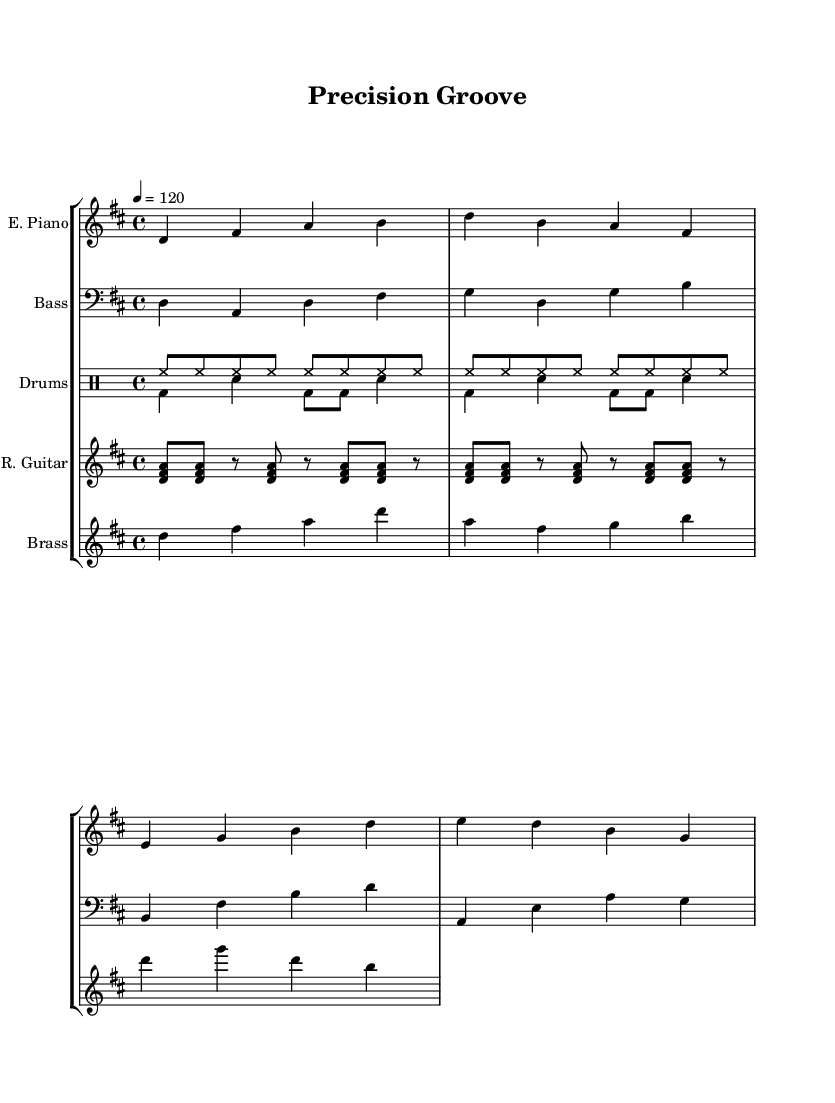What is the key signature of this music? The key signature shows two sharps, which indicate it is in the key of D major.
Answer: D major What is the time signature of this piece? The time signature is indicated by the fraction at the beginning of the score, which shows 4/4, meaning there are four beats in each measure.
Answer: 4/4 What is the tempo marking? The tempo is indicated as 4 equals 120, meaning there are 120 quarter note beats per minute.
Answer: 120 What type of instrumentation is featured in this music? The score lists six staffs, comprising electric piano, bass guitar, drums, rhythm guitar, and brass section, indicating a mix of keyboard, percussion, and harmony instruments typical in soul funk.
Answer: Electric piano, bass, drums, rhythm guitar, brass How many measures are there in the electric piano part? Counting the measures indicated in the electric piano part, there are a total of four measures shown in the music.
Answer: Four Which rhythmic section emphasizes the groove in the arrangement? The rhythm guitar plays a syncopated part in eighth notes, contributing to the overall funk feel that emphasizes tight, synchronized rhythms typical in soul music.
Answer: Rhythm guitar What is the significance of the brass section in this piece? The brass section plays a riff that provides harmony and depth, which is vital in soul and funk for enriching the sound and creating a punchy, melodic counterpoint.
Answer: Brass section plays a riff 